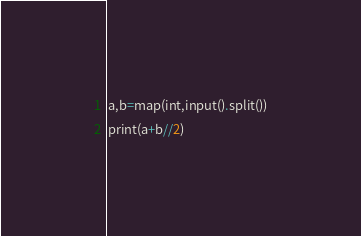<code> <loc_0><loc_0><loc_500><loc_500><_Python_>a,b=map(int,input().split())
print(a+b//2)
</code> 